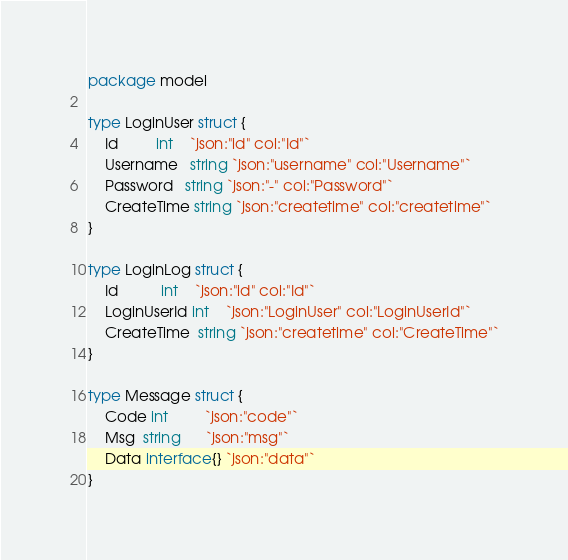Convert code to text. <code><loc_0><loc_0><loc_500><loc_500><_Go_>package model

type LoginUser struct {
	Id         int    `json:"id" col:"Id"`
	Username   string `json:"username" col:"Username"`
	Password   string `json:"-" col:"Password"`
	CreateTime string `json:"createtime" col:"createtime"`
}

type LoginLog struct {
	Id          int    `json:"id" col:"Id"`
	LoginUserId int    `json:"LoginUser" col:"LoginUserId"`
	CreateTime  string `json:"createtime" col:"CreateTime"`
}

type Message struct {
	Code int         `json:"code"`
	Msg  string      `json:"msg"`
	Data interface{} `json:"data"`
}
</code> 